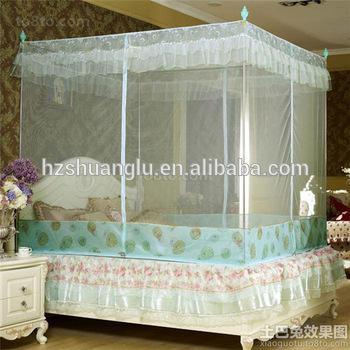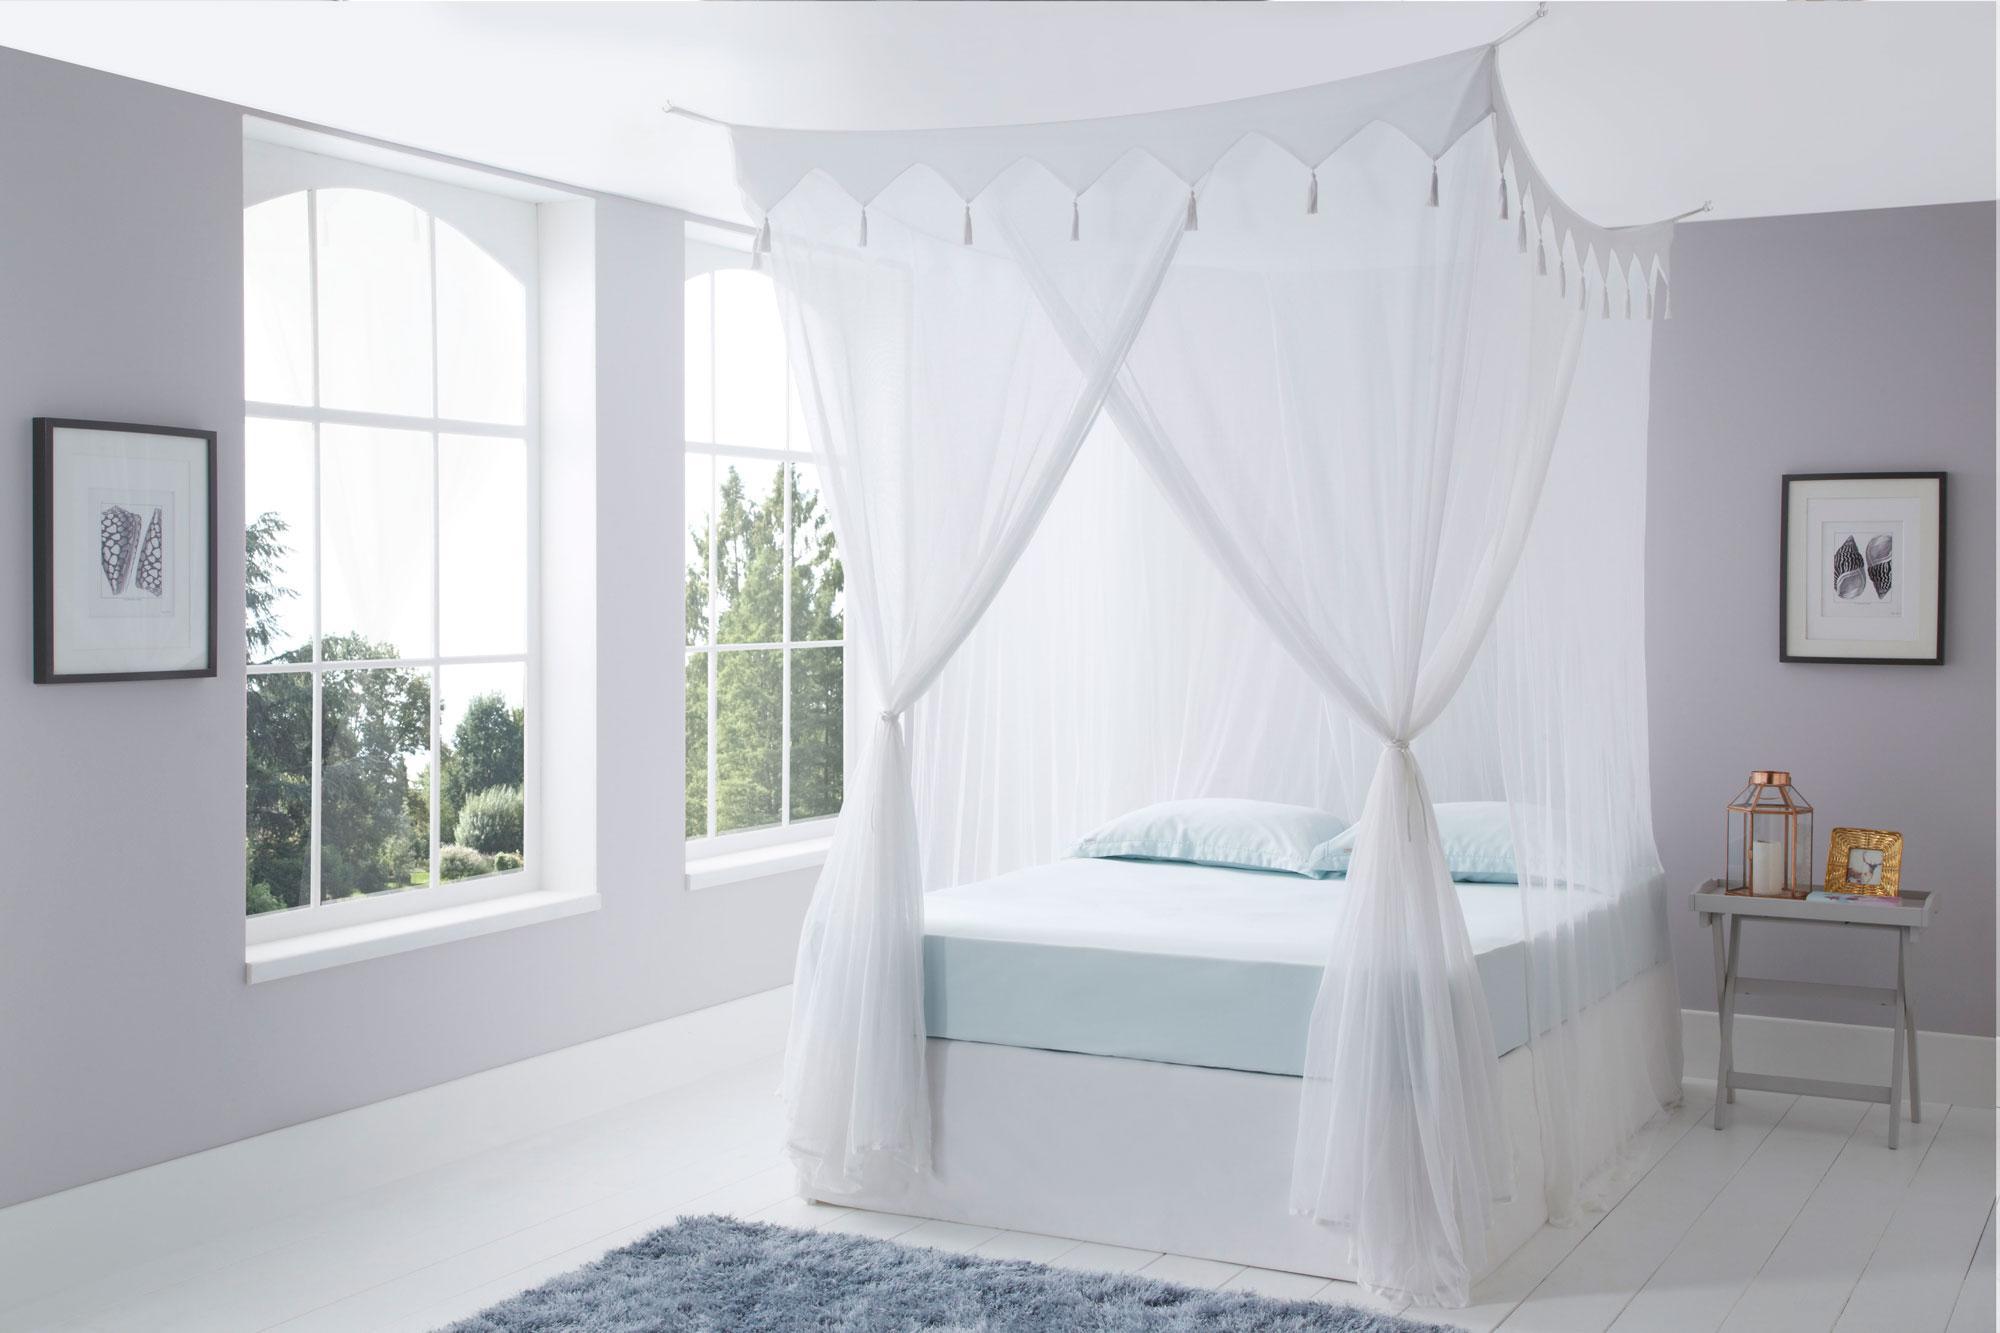The first image is the image on the left, the second image is the image on the right. Assess this claim about the two images: "Exactly one bed net is attached to the ceiling.". Correct or not? Answer yes or no. Yes. 